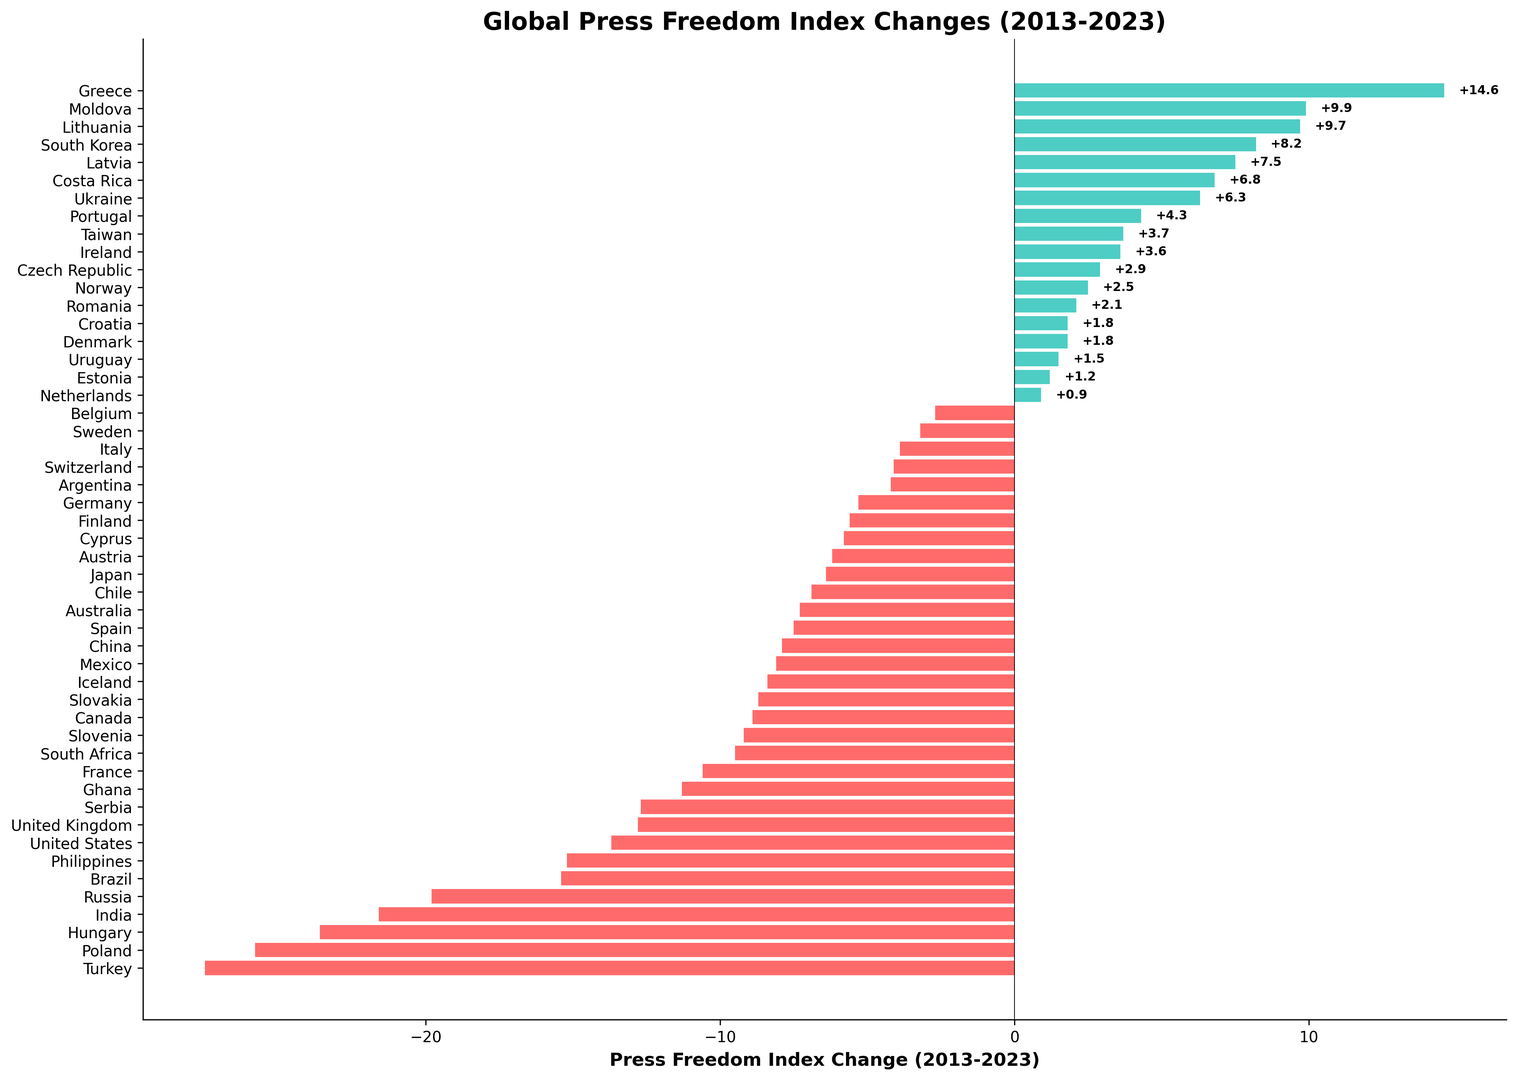What's the country with the largest improvement in press freedom index? The largest green bar on the right represents the country with the largest positive change. By identifying the longest green bar visually, we see that Greece has the largest improvement of 14.6.
Answer: Greece Which country experienced the largest decline in the press freedom index? The longest red bar on the left represents the country with the largest negative change. By identifying this bar, we see that Turkey experienced the largest decline of -27.5.
Answer: Turkey How many countries have improved their press freedom index? Green bars represent countries with positive changes. By counting the green bars, we find that there are 17 countries with improvements.
Answer: 17 Which country had the smallest improvement in press freedom index? Among the green bars, the shortest one signifies the smallest improvement. By identifying the shortest green bar, we see that Netherlands had the smallest improvement of 0.9.
Answer: Netherlands What is the total press freedom index change for countries that experienced a decline? We need to sum the values of all the red bars (negative changes). Adding up these values gives a total of -319.8.
Answer: -319.8 What is the average press freedom index change for countries that had an improvement? First, sum the values of all green bars (positive changes), then divide by the number of countries with improvements. The total improvement sum is 82.2 and there are 17 improving countries: 82.2 / 17 = 4.8
Answer: 4.8 Compare the press freedom index change between Norway and South Korea. Locate the bars for Norway and South Korea. Norway has a change of 2.5 while South Korea has 8.2. South Korea has a higher improvement.
Answer: South Korea Which countries had changes between -10 and -15? Identify red bars with values between -10 and -15. The countries are France (-10.6), United States (-13.7), Brazil (-15.4), Philippines (-15.2).
Answer: France, United States, Brazil, Philippines Which country shows exactly a change of 2.1 in press freedom index? Locate the bar with a value of 2.1. It is Romania.
Answer: Romania 